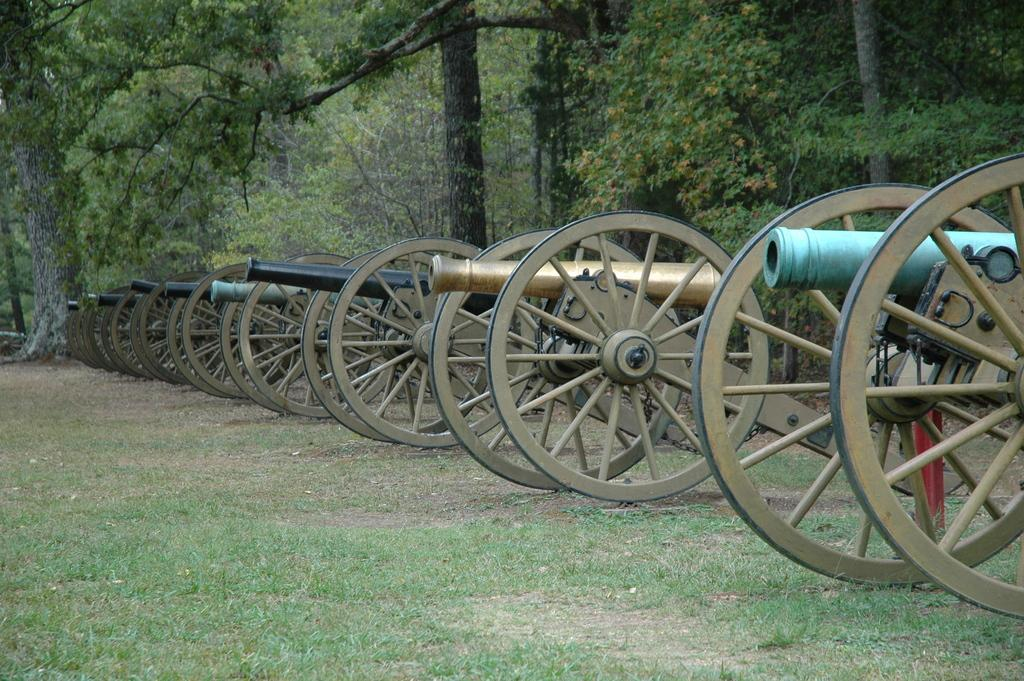What type of objects are present in the image? There are cannons in the image. What is the color and texture of the ground in the image? There is green grass visible in the image. What can be seen in the distance in the image? There are trees in the background of the image. What grade is the student receiving in the image? There is no student or grade present in the image. 